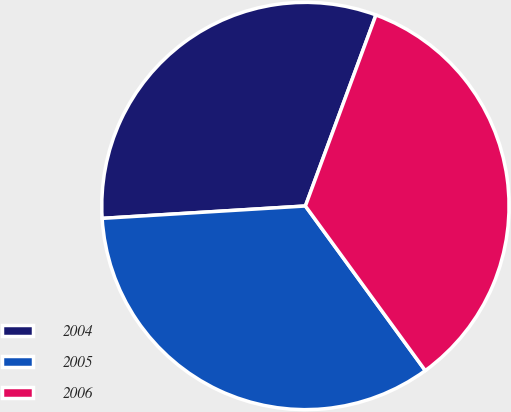Convert chart to OTSL. <chart><loc_0><loc_0><loc_500><loc_500><pie_chart><fcel>2004<fcel>2005<fcel>2006<nl><fcel>31.6%<fcel>34.05%<fcel>34.35%<nl></chart> 